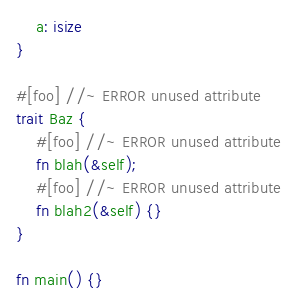Convert code to text. <code><loc_0><loc_0><loc_500><loc_500><_Rust_>    a: isize
}

#[foo] //~ ERROR unused attribute
trait Baz {
    #[foo] //~ ERROR unused attribute
    fn blah(&self);
    #[foo] //~ ERROR unused attribute
    fn blah2(&self) {}
}

fn main() {}
</code> 